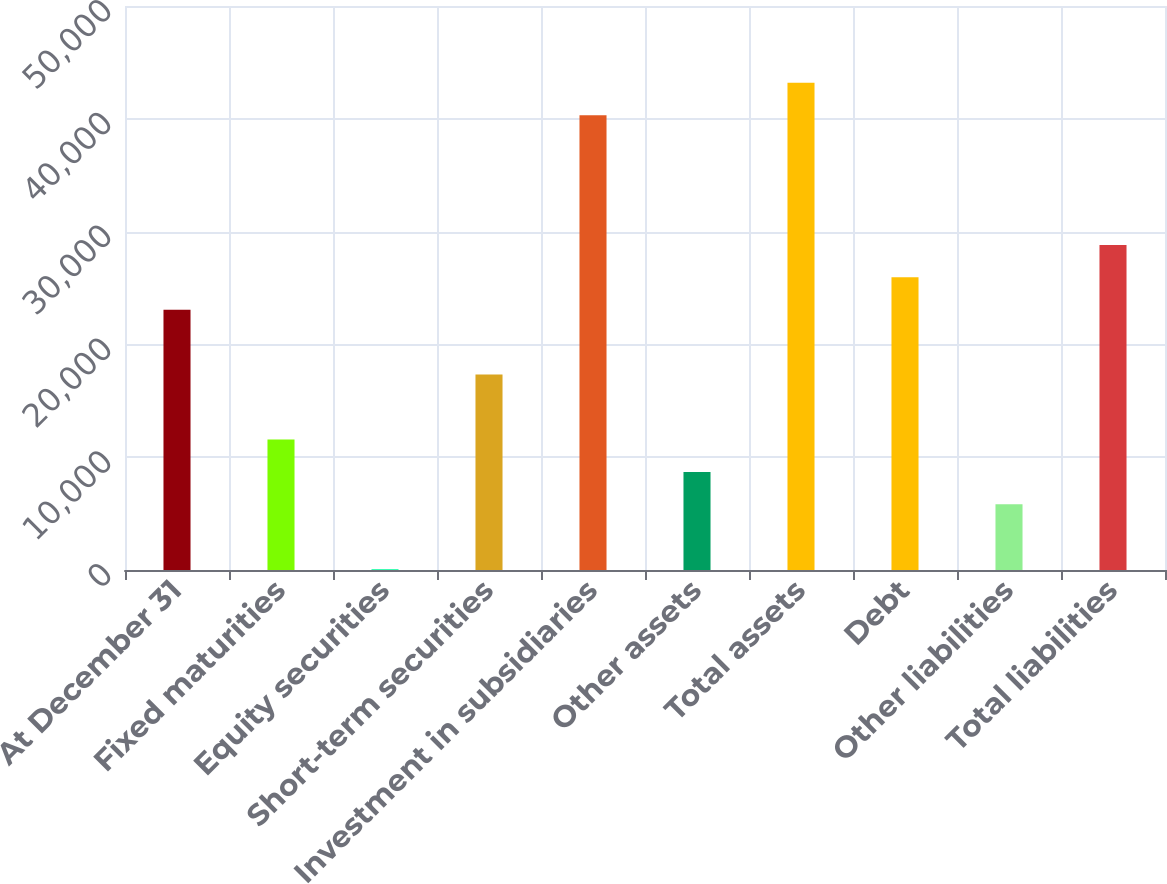Convert chart. <chart><loc_0><loc_0><loc_500><loc_500><bar_chart><fcel>At December 31<fcel>Fixed maturities<fcel>Equity securities<fcel>Short-term securities<fcel>Investment in subsidiaries<fcel>Other assets<fcel>Total assets<fcel>Debt<fcel>Other liabilities<fcel>Total liabilities<nl><fcel>23071.8<fcel>11569.4<fcel>67<fcel>17320.6<fcel>40325.4<fcel>8693.8<fcel>43201<fcel>25947.4<fcel>5818.2<fcel>28823<nl></chart> 